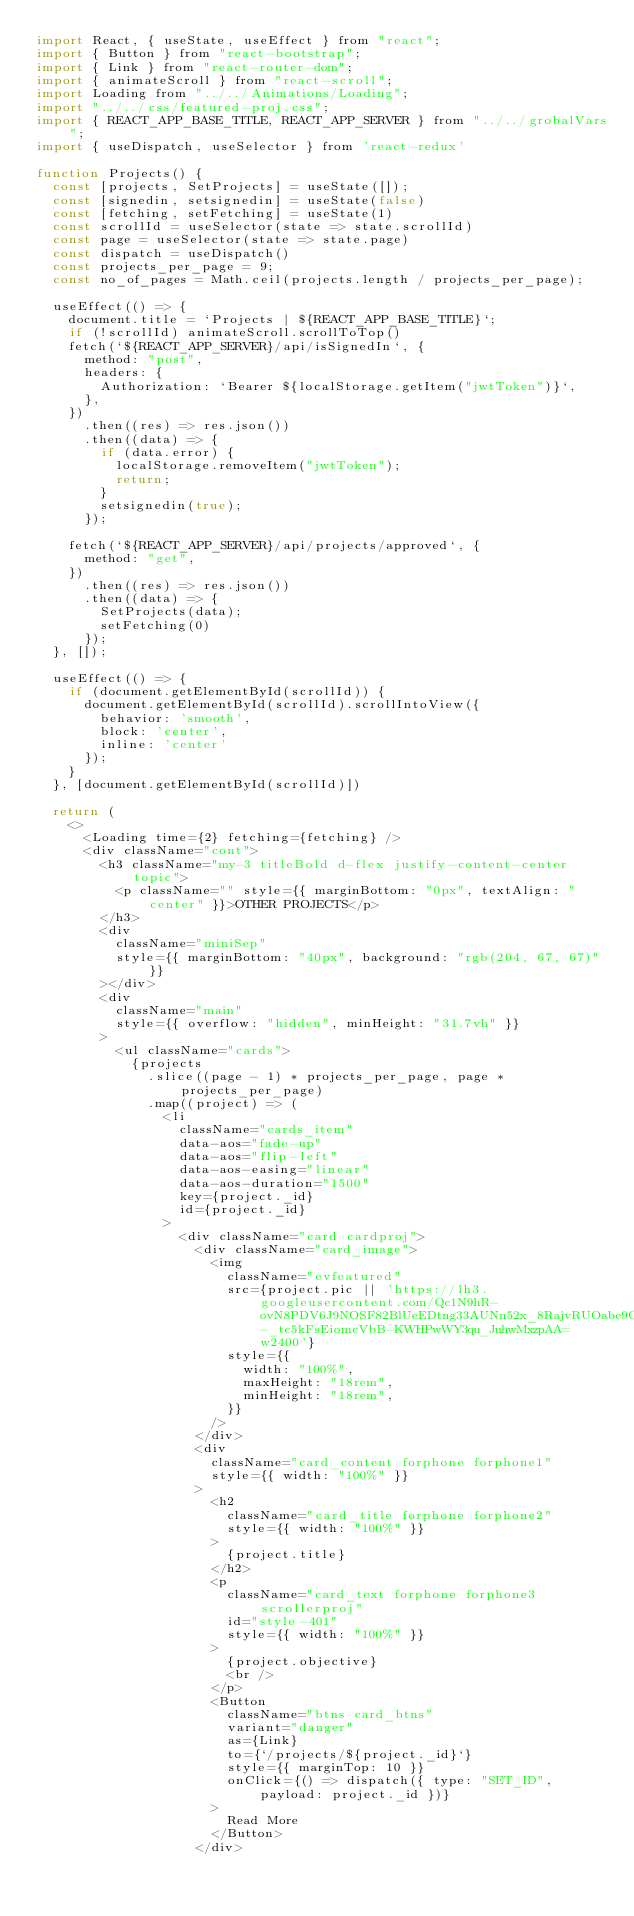Convert code to text. <code><loc_0><loc_0><loc_500><loc_500><_JavaScript_>import React, { useState, useEffect } from "react";
import { Button } from "react-bootstrap";
import { Link } from "react-router-dom";
import { animateScroll } from "react-scroll";
import Loading from "../../Animations/Loading";
import "../../css/featured-proj.css";
import { REACT_APP_BASE_TITLE, REACT_APP_SERVER } from "../../grobalVars";
import { useDispatch, useSelector } from 'react-redux'

function Projects() {
  const [projects, SetProjects] = useState([]);
  const [signedin, setsignedin] = useState(false)
  const [fetching, setFetching] = useState(1)
  const scrollId = useSelector(state => state.scrollId)
  const page = useSelector(state => state.page)
  const dispatch = useDispatch()
  const projects_per_page = 9;
  const no_of_pages = Math.ceil(projects.length / projects_per_page);

  useEffect(() => {
    document.title = `Projects | ${REACT_APP_BASE_TITLE}`;
    if (!scrollId) animateScroll.scrollToTop()
    fetch(`${REACT_APP_SERVER}/api/isSignedIn`, {
      method: "post",
      headers: {
        Authorization: `Bearer ${localStorage.getItem("jwtToken")}`,
      },
    })
      .then((res) => res.json())
      .then((data) => {
        if (data.error) {
          localStorage.removeItem("jwtToken");
          return;
        }
        setsignedin(true);
      });

    fetch(`${REACT_APP_SERVER}/api/projects/approved`, {
      method: "get",
    })
      .then((res) => res.json())
      .then((data) => {
        SetProjects(data);
        setFetching(0)
      });
  }, []);

  useEffect(() => {
    if (document.getElementById(scrollId)) {
      document.getElementById(scrollId).scrollIntoView({
        behavior: 'smooth',
        block: 'center',
        inline: 'center'
      });
    }
  }, [document.getElementById(scrollId)])

  return (
    <>
      <Loading time={2} fetching={fetching} />
      <div className="cont">
        <h3 className="my-3 titleBold d-flex justify-content-center topic">
          <p className="" style={{ marginBottom: "0px", textAlign: "center" }}>OTHER PROJECTS</p>
        </h3>
        <div
          className="miniSep"
          style={{ marginBottom: "40px", background: "rgb(204, 67, 67)" }}
        ></div>
        <div
          className="main"
          style={{ overflow: "hidden", minHeight: "31.7vh" }}
        >
          <ul className="cards">
            {projects
              .slice((page - 1) * projects_per_page, page * projects_per_page)
              .map((project) => (
                <li
                  className="cards_item"
                  data-aos="fade-up"
                  data-aos="flip-left"
                  data-aos-easing="linear"
                  data-aos-duration="1500"
                  key={project._id}
                  id={project._id}
                >
                  <div className="card cardproj">
                    <div className="card_image">
                      <img
                        className="evfeatured"
                        src={project.pic || 'https://lh3.googleusercontent.com/Qc1N9hR-ovN8PDV6J9NOSF82BlUeEDtng33AUNn52x_8RajvRUOabe9C62hmtuWLRgPyjkXv6VbOG7PES8K3ZzWYFxyLuJSGIihC-_tc5kFsEiomcVbB-KWHPwWY3qu_JuhwMxzpAA=w2400'}
                        style={{
                          width: "100%",
                          maxHeight: "18rem",
                          minHeight: "18rem",
                        }}
                      />
                    </div>
                    <div
                      className="card_content forphone forphone1"
                      style={{ width: "100%" }}
                    >
                      <h2
                        className="card_title forphone forphone2"
                        style={{ width: "100%" }}
                      >
                        {project.title}
                      </h2>
                      <p
                        className="card_text forphone forphone3 scrollerproj"
                        id="style-401"
                        style={{ width: "100%" }}
                      >
                        {project.objective}
                        <br />
                      </p>
                      <Button
                        className="btns card_btns"
                        variant="danger"
                        as={Link}
                        to={`/projects/${project._id}`}
                        style={{ marginTop: 10 }}
                        onClick={() => dispatch({ type: "SET_ID", payload: project._id })}
                      >
                        Read More
                      </Button>
                    </div></code> 